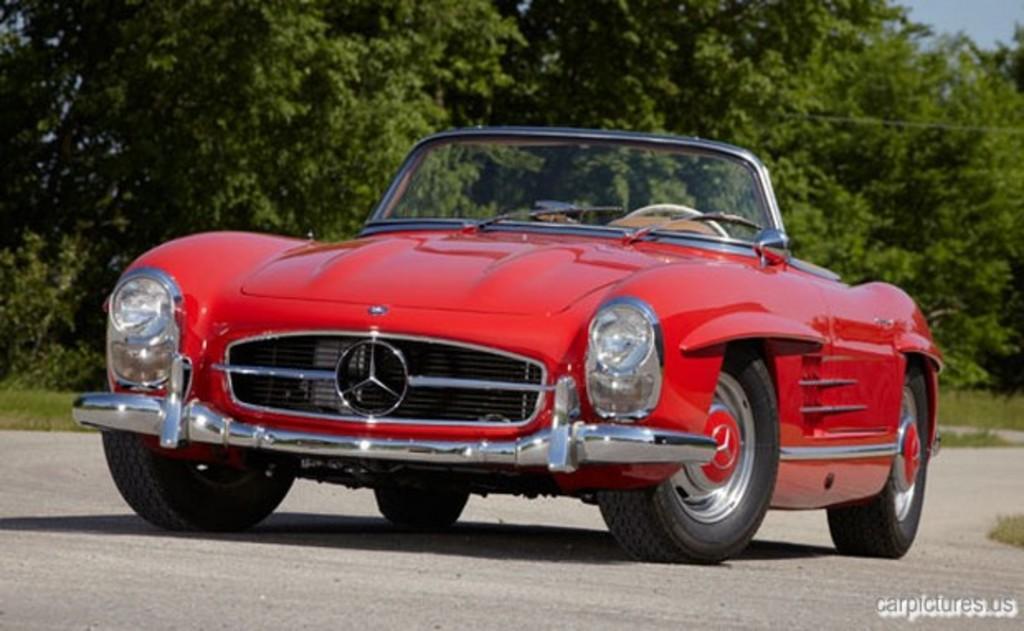Please provide a concise description of this image. In this image we can see a car on the road and a few trees and the sky in the background. 